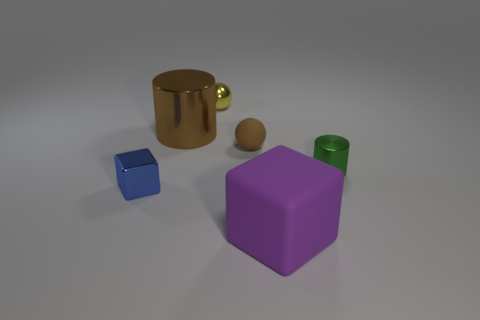There is a rubber sphere that is the same color as the large metal cylinder; what is its size?
Give a very brief answer. Small. There is another object that is the same color as the large metallic thing; what shape is it?
Your response must be concise. Sphere. Is there a metal sphere of the same size as the green metallic cylinder?
Offer a terse response. Yes. There is a tiny blue block that is left of the cylinder that is on the right side of the ball in front of the tiny yellow ball; what is its material?
Give a very brief answer. Metal. How many yellow metallic things are on the right side of the big object in front of the blue metallic cube?
Keep it short and to the point. 0. Do the cylinder that is left of the green cylinder and the big purple object have the same size?
Provide a succinct answer. Yes. What number of other objects are the same shape as the tiny yellow shiny thing?
Ensure brevity in your answer.  1. What is the shape of the tiny matte object?
Ensure brevity in your answer.  Sphere. Are there the same number of blue objects that are to the right of the small green metal cylinder and objects?
Ensure brevity in your answer.  No. Are the cylinder that is on the left side of the tiny green shiny cylinder and the blue thing made of the same material?
Offer a terse response. Yes. 